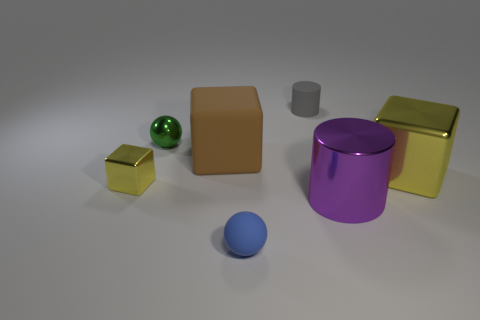Subtract all cyan cylinders. How many yellow cubes are left? 2 Subtract all shiny cubes. How many cubes are left? 1 Add 2 tiny shiny spheres. How many objects exist? 9 Subtract all balls. How many objects are left? 5 Add 1 small yellow metallic cubes. How many small yellow metallic cubes exist? 2 Subtract 0 yellow cylinders. How many objects are left? 7 Subtract all green spheres. Subtract all red blocks. How many spheres are left? 1 Subtract all small red cylinders. Subtract all tiny cylinders. How many objects are left? 6 Add 7 small blue matte balls. How many small blue matte balls are left? 8 